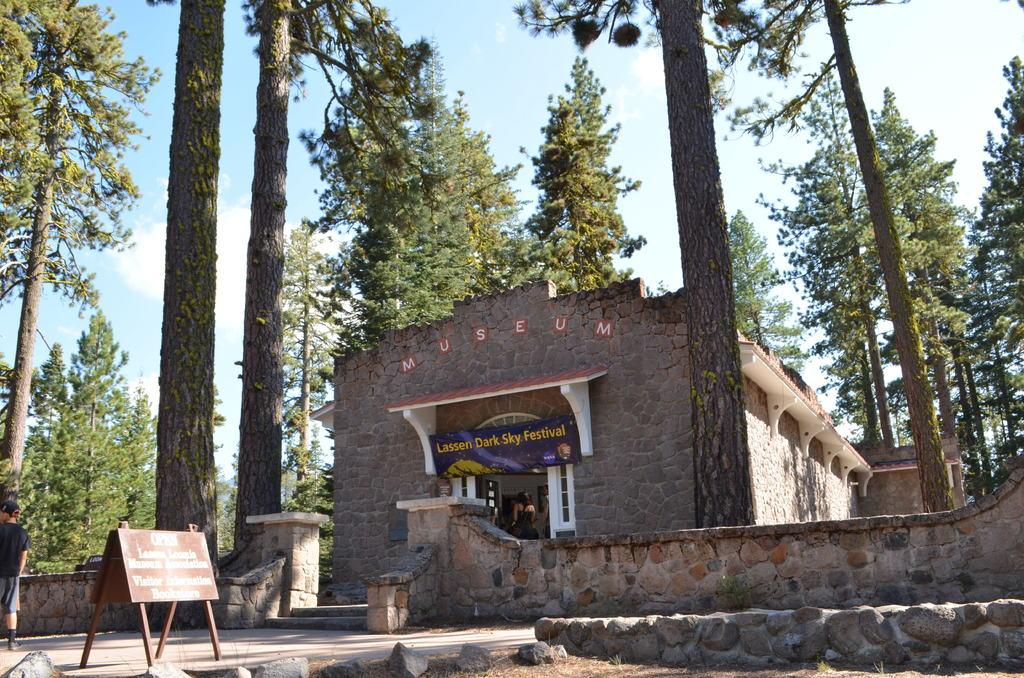What type of structure is visible in the image? There is a house in the image. What materials are present in the image? There are boards and walls visible in the image. What type of vegetation can be seen in the image? There are trees in the image. Who or what is present in the image? There are people in the image. What is visible in the background of the image? The sky is visible in the background of the image, and there are clouds in the sky. Can you tell me what the beggar is saying to the sheep in the image? There is no beggar or sheep present in the image. 